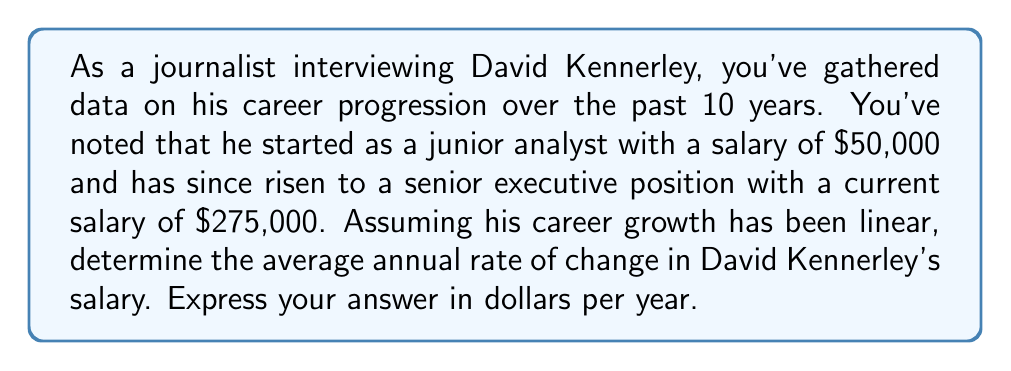Can you answer this question? To solve this problem, we need to use the concept of rate of change in a linear equation. The rate of change is the slope of the line representing David Kennerley's salary over time.

Given:
- Initial salary (y₁): $50,000
- Current salary (y₂): $275,000
- Time span (x₂ - x₁): 10 years

We can use the slope formula:

$$ m = \frac{y_2 - y_1}{x_2 - x_1} $$

Where:
m = rate of change (slope)
y₂ - y₁ = change in salary
x₂ - x₁ = change in time

Let's plug in the values:

$$ m = \frac{275,000 - 50,000}{10 - 0} $$

$$ m = \frac{225,000}{10} $$

$$ m = 22,500 $$

This means that David Kennerley's salary increased by an average of $22,500 per year over the 10-year period.
Answer: $22,500 per year 